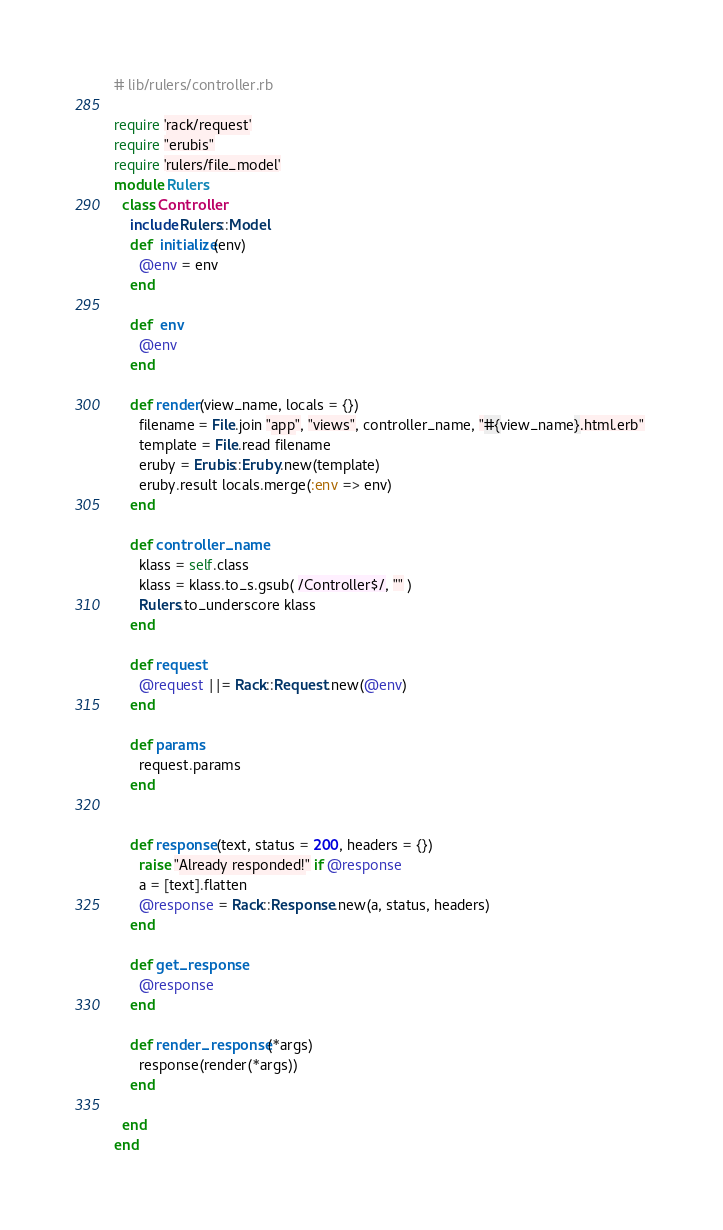<code> <loc_0><loc_0><loc_500><loc_500><_Ruby_># lib/rulers/controller.rb

require 'rack/request'
require "erubis"
require 'rulers/file_model'
module Rulers
  class Controller
    include Rulers::Model
    def  initialize(env)
      @env = env
    end

    def  env
      @env
    end

    def render(view_name, locals = {})
      filename = File.join "app", "views", controller_name, "#{view_name}.html.erb" 
      template = File.read filename
      eruby = Erubis::Eruby.new(template)
      eruby.result locals.merge(:env => env)
    end

    def controller_name
      klass = self.class
      klass = klass.to_s.gsub( /Controller$/, "" )
      Rulers.to_underscore klass
    end

    def request
      @request ||= Rack::Request.new(@env)
    end

    def params
      request.params 
    end


    def response(text, status = 200, headers = {})
      raise "Already responded!" if @response
      a = [text].flatten
      @response = Rack::Response.new(a, status, headers)
    end

    def get_response
      @response
    end

    def render_response(*args)
      response(render(*args))
    end

  end
end 
</code> 